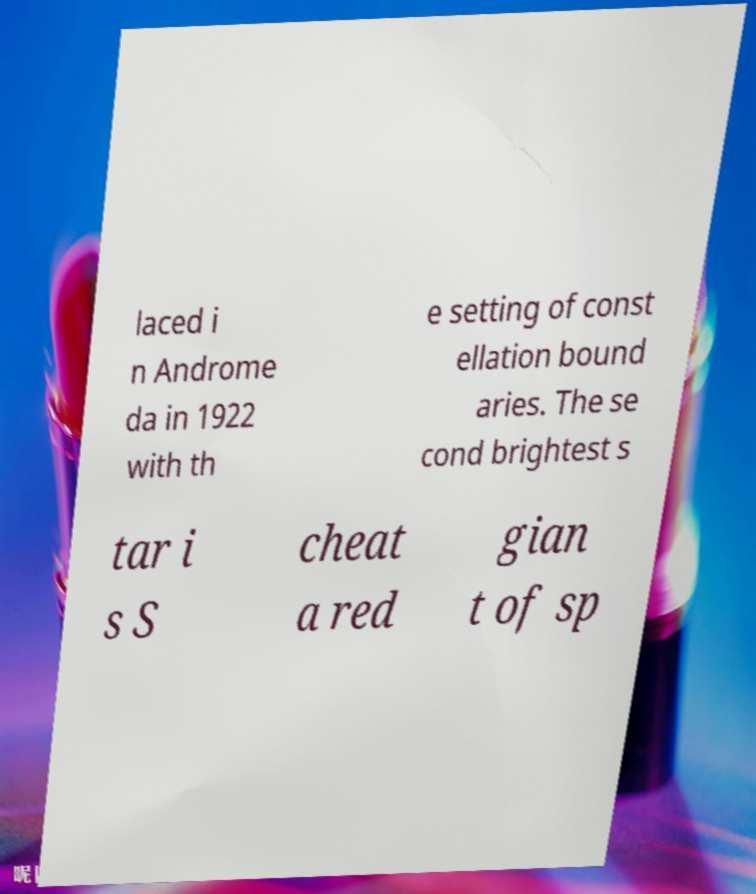Can you accurately transcribe the text from the provided image for me? laced i n Androme da in 1922 with th e setting of const ellation bound aries. The se cond brightest s tar i s S cheat a red gian t of sp 